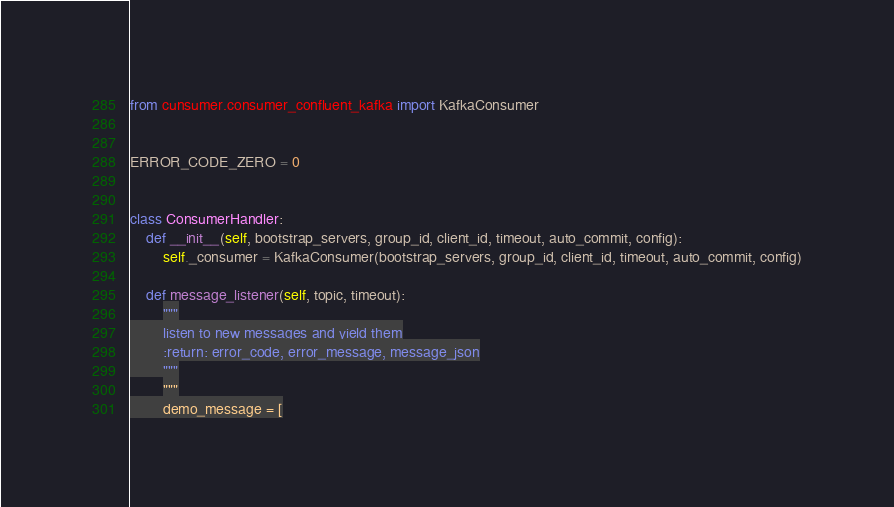<code> <loc_0><loc_0><loc_500><loc_500><_Python_>from cunsumer.consumer_confluent_kafka import KafkaConsumer


ERROR_CODE_ZERO = 0


class ConsumerHandler:
    def __init__(self, bootstrap_servers, group_id, client_id, timeout, auto_commit, config):
        self._consumer = KafkaConsumer(bootstrap_servers, group_id, client_id, timeout, auto_commit, config)

    def message_listener(self, topic, timeout):
        """
        listen to new messages and yield them
        :return: error_code, error_message, message_json
        """
        """
        demo_message = [</code> 